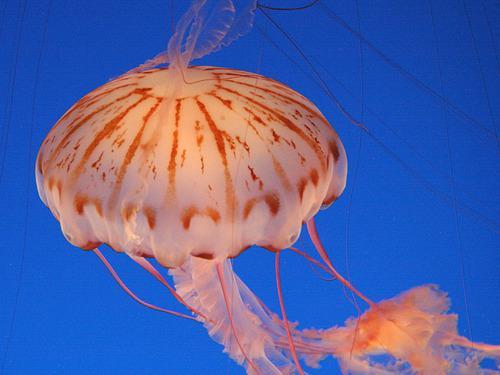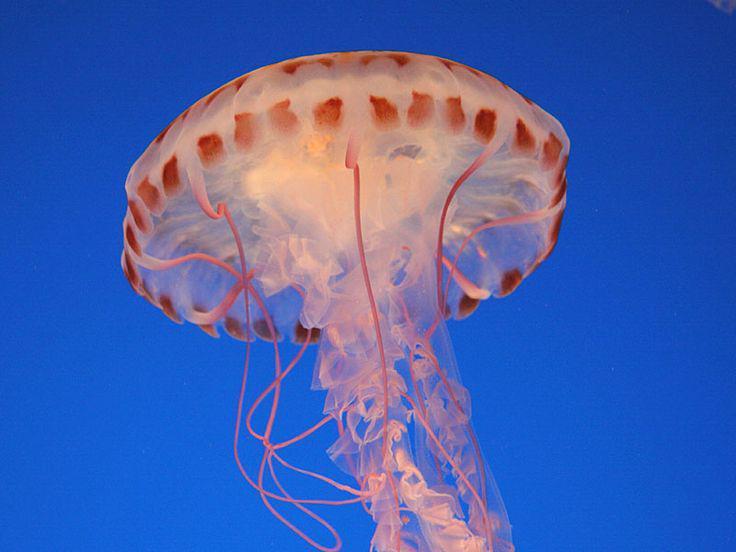The first image is the image on the left, the second image is the image on the right. Examine the images to the left and right. Is the description "Two jellyfish are visible in the left image." accurate? Answer yes or no. No. 